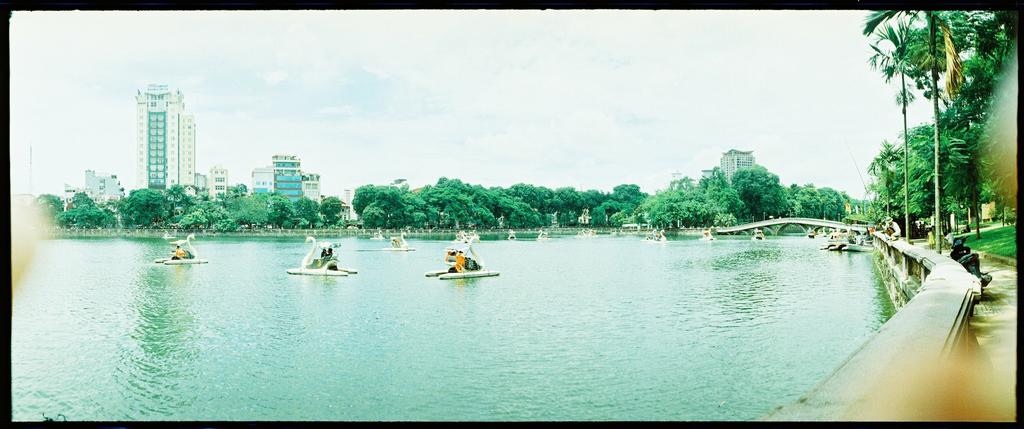What are the people in the image doing? The people are riding swan pedal boats in the image. Where are the swan pedal boats located? The swan pedal boats are on the water. What can be seen in the background of the image? In the background of the image, there are trees, a vehicle, iron grills, a bridge, plants, buildings, and poles. The sky is also visible. What type of dinner is being served on the swan pedal boats in the image? There is no dinner being served on the swan pedal boats in the image; the people are simply riding them on the water. What act is being performed by the swan pedal boats in the image? Swan pedal boats are not performing any act in the image; they are being ridden by people. 